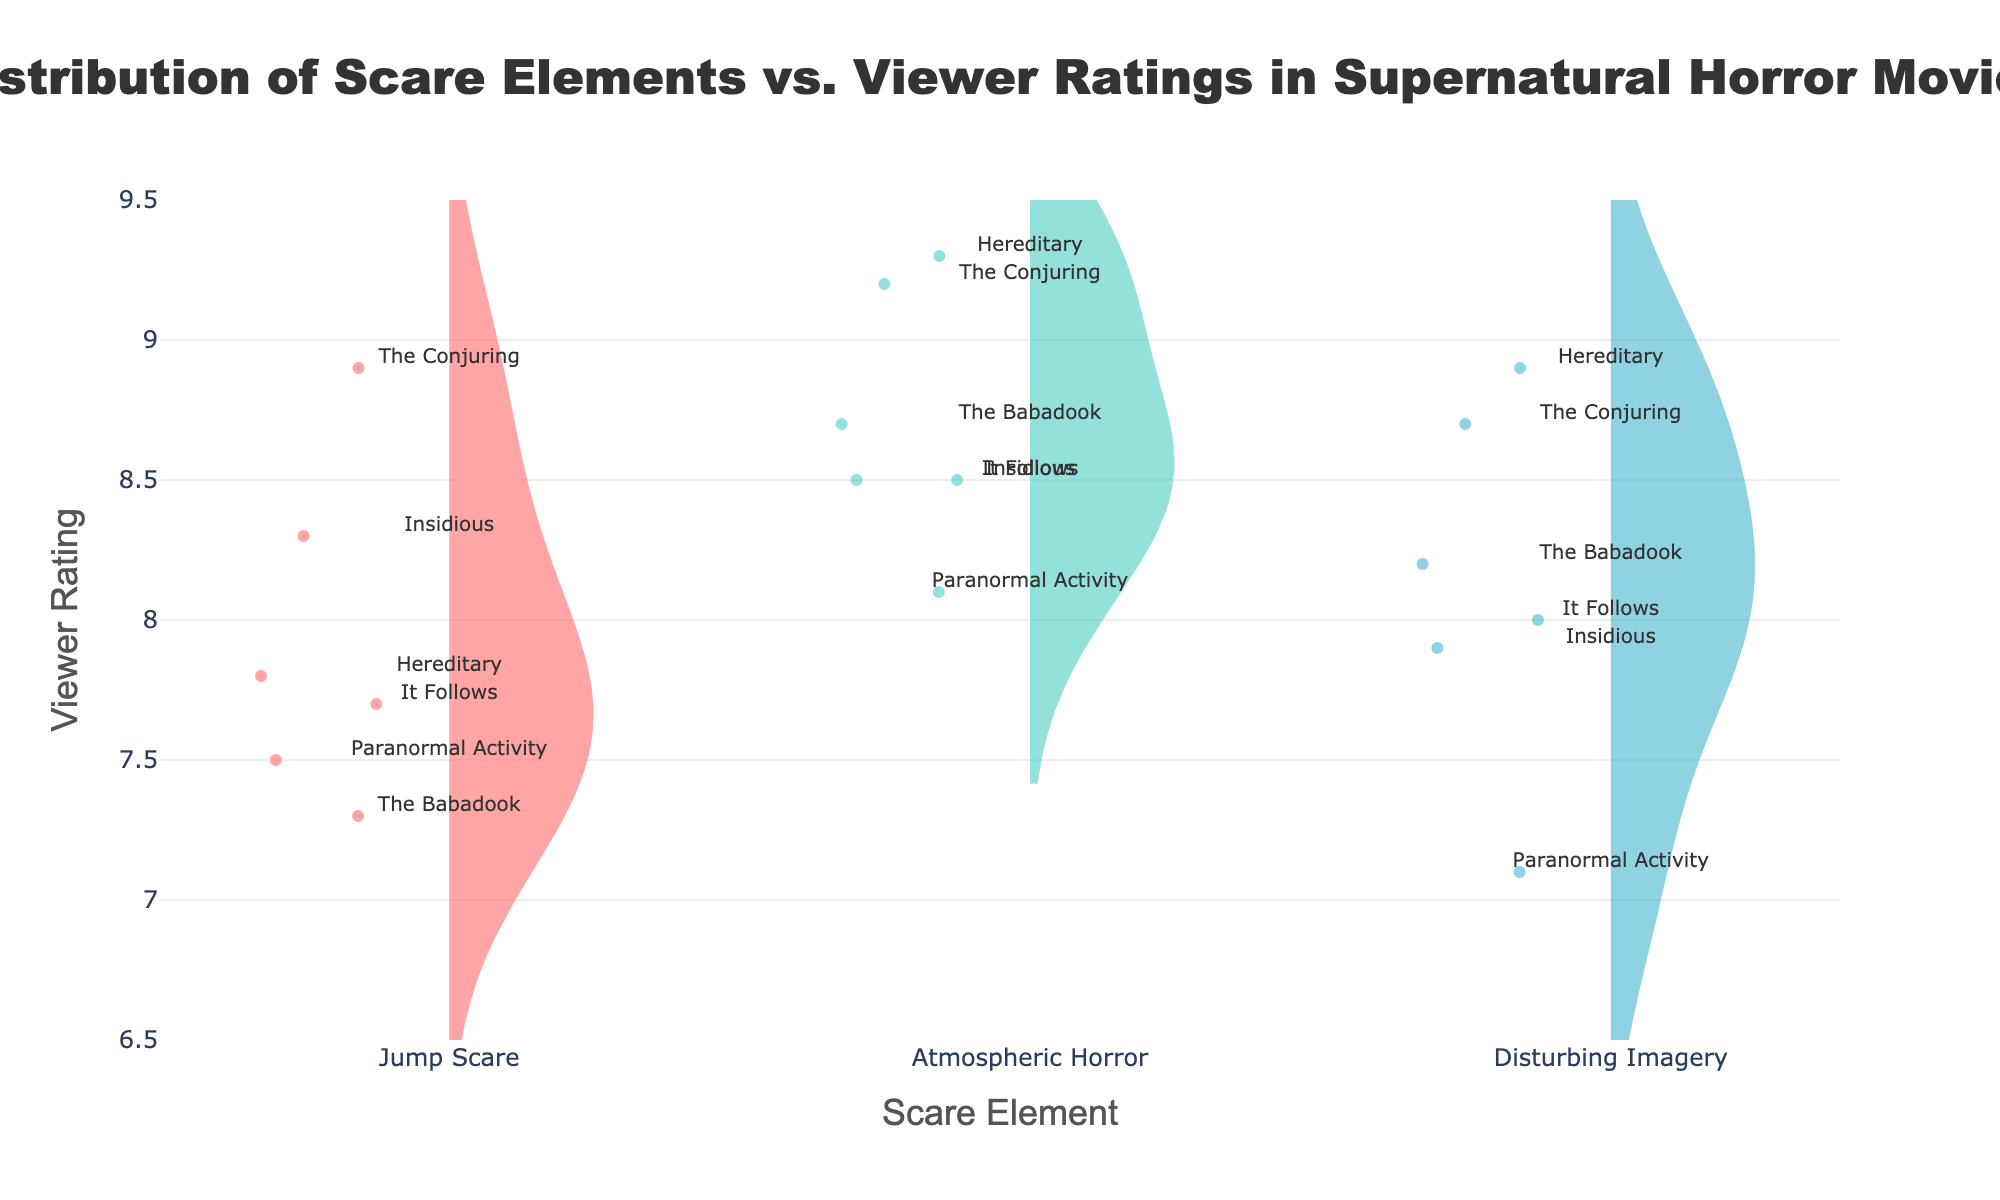What are the scare elements analyzed in the figure? The figure focuses on three categories of scare elements, which are clearly labeled on the x-axis as Violin plots. These categories are "Jump Scare," "Atmospheric Horror," and "Disturbing Imagery."
Answer: Jump Scare, Atmospheric Horror, Disturbing Imagery Which movie has the highest viewer rating for atmospheric horror? Look at the "Atmospheric Horror" violin plot and identify the data point with the highest value. The label near the topmost data point corresponds to the movie "Hereditary."
Answer: Hereditary What is the range of viewer ratings for disturbing imagery? Check the y-axis values associated with the "Disturbing Imagery" violin plot. The highest data point is at 8.9, and the lowest is 7.1. Calculate the range by subtracting the lowest from the highest.
Answer: 8.9 - 7.1 = 1.8 Which scare element shows the highest average viewer rating? Look at the mean lines (horizontal lines) within each violin plot, which represent the average. The highest mean line is located in the "Atmospheric Horror" category.
Answer: Atmospheric Horror Is there a significant spread in viewer ratings for jump scares compared to atmospheric horror? Compare the widths of the violin plots for "Jump Scare" and "Atmospheric Horror." The wider the plot, the more significant the spread. "Jump Scare" has a broader distribution compared to "Atmospheric Horror."
Answer: Yes Which movie appears to have the lowest viewer rating for disturbing imagery? Look at the bottommost data point within the "Disturbing Imagery" violin plot and identify the movie label associated with it. The label points to "Paranormal Activity."
Answer: Paranormal Activity How does the median viewer rating for jump scares compare to the median for atmospheric horror? Check the box (rectangle) inside each violin plot, which represents the interquartile range. The line inside the box is the median. Compare the median lines for both "Jump Scare" and "Atmospheric Horror." The median for atmospheric horror is higher.
Answer: Atmospheric Horror median is higher What is the typical viewer rating range for atmospheric horror in the movies analyzed? Focus on the general distribution within the "Atmospheric Horror" violin plot. Most data points fall between 8.1 and 9.3.
Answer: 8.1 - 9.3 Which movie has the smallest variation in viewer ratings across all scare elements? Identify the movie whose labels in the figure are closely clustered together, suggesting low variation. "Paranormal Activity" has the closest clustering of its labels across the three scare elements.
Answer: Paranormal Activity 